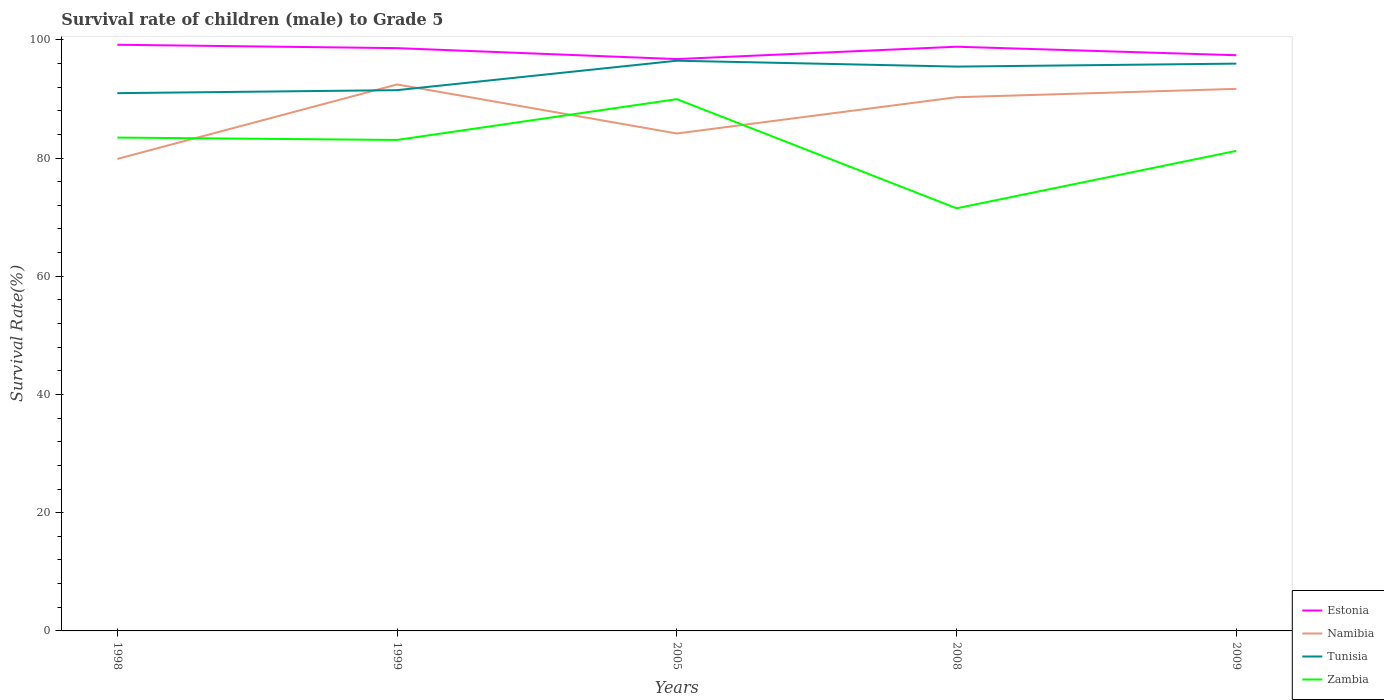Is the number of lines equal to the number of legend labels?
Your answer should be very brief. Yes. Across all years, what is the maximum survival rate of male children to grade 5 in Tunisia?
Ensure brevity in your answer.  90.97. In which year was the survival rate of male children to grade 5 in Estonia maximum?
Provide a succinct answer. 2005. What is the total survival rate of male children to grade 5 in Estonia in the graph?
Make the answer very short. 1.2. What is the difference between the highest and the second highest survival rate of male children to grade 5 in Estonia?
Give a very brief answer. 2.42. What is the difference between the highest and the lowest survival rate of male children to grade 5 in Zambia?
Ensure brevity in your answer.  3. How many years are there in the graph?
Offer a terse response. 5. Does the graph contain any zero values?
Ensure brevity in your answer.  No. Does the graph contain grids?
Your answer should be very brief. No. Where does the legend appear in the graph?
Your response must be concise. Bottom right. How many legend labels are there?
Your answer should be very brief. 4. How are the legend labels stacked?
Offer a terse response. Vertical. What is the title of the graph?
Offer a very short reply. Survival rate of children (male) to Grade 5. What is the label or title of the X-axis?
Offer a terse response. Years. What is the label or title of the Y-axis?
Keep it short and to the point. Survival Rate(%). What is the Survival Rate(%) in Estonia in 1998?
Offer a terse response. 99.16. What is the Survival Rate(%) of Namibia in 1998?
Your answer should be very brief. 79.85. What is the Survival Rate(%) in Tunisia in 1998?
Provide a short and direct response. 90.97. What is the Survival Rate(%) in Zambia in 1998?
Make the answer very short. 83.46. What is the Survival Rate(%) of Estonia in 1999?
Keep it short and to the point. 98.59. What is the Survival Rate(%) in Namibia in 1999?
Your answer should be compact. 92.45. What is the Survival Rate(%) of Tunisia in 1999?
Keep it short and to the point. 91.48. What is the Survival Rate(%) in Zambia in 1999?
Provide a short and direct response. 83.06. What is the Survival Rate(%) of Estonia in 2005?
Offer a very short reply. 96.74. What is the Survival Rate(%) of Namibia in 2005?
Give a very brief answer. 84.15. What is the Survival Rate(%) of Tunisia in 2005?
Your answer should be compact. 96.46. What is the Survival Rate(%) of Zambia in 2005?
Your answer should be very brief. 89.96. What is the Survival Rate(%) in Estonia in 2008?
Offer a terse response. 98.83. What is the Survival Rate(%) in Namibia in 2008?
Your answer should be very brief. 90.28. What is the Survival Rate(%) of Tunisia in 2008?
Your answer should be compact. 95.47. What is the Survival Rate(%) of Zambia in 2008?
Ensure brevity in your answer.  71.5. What is the Survival Rate(%) of Estonia in 2009?
Give a very brief answer. 97.39. What is the Survival Rate(%) in Namibia in 2009?
Offer a terse response. 91.7. What is the Survival Rate(%) in Tunisia in 2009?
Provide a short and direct response. 95.97. What is the Survival Rate(%) in Zambia in 2009?
Your answer should be very brief. 81.21. Across all years, what is the maximum Survival Rate(%) in Estonia?
Provide a succinct answer. 99.16. Across all years, what is the maximum Survival Rate(%) in Namibia?
Your answer should be compact. 92.45. Across all years, what is the maximum Survival Rate(%) of Tunisia?
Keep it short and to the point. 96.46. Across all years, what is the maximum Survival Rate(%) of Zambia?
Your answer should be very brief. 89.96. Across all years, what is the minimum Survival Rate(%) in Estonia?
Offer a terse response. 96.74. Across all years, what is the minimum Survival Rate(%) of Namibia?
Offer a very short reply. 79.85. Across all years, what is the minimum Survival Rate(%) of Tunisia?
Provide a short and direct response. 90.97. Across all years, what is the minimum Survival Rate(%) of Zambia?
Make the answer very short. 71.5. What is the total Survival Rate(%) in Estonia in the graph?
Offer a very short reply. 490.71. What is the total Survival Rate(%) in Namibia in the graph?
Offer a very short reply. 438.43. What is the total Survival Rate(%) in Tunisia in the graph?
Your response must be concise. 470.36. What is the total Survival Rate(%) in Zambia in the graph?
Your answer should be very brief. 409.19. What is the difference between the Survival Rate(%) of Estonia in 1998 and that in 1999?
Give a very brief answer. 0.57. What is the difference between the Survival Rate(%) of Namibia in 1998 and that in 1999?
Offer a terse response. -12.6. What is the difference between the Survival Rate(%) in Tunisia in 1998 and that in 1999?
Your response must be concise. -0.51. What is the difference between the Survival Rate(%) in Zambia in 1998 and that in 1999?
Make the answer very short. 0.4. What is the difference between the Survival Rate(%) in Estonia in 1998 and that in 2005?
Provide a short and direct response. 2.42. What is the difference between the Survival Rate(%) of Namibia in 1998 and that in 2005?
Offer a terse response. -4.31. What is the difference between the Survival Rate(%) of Tunisia in 1998 and that in 2005?
Your response must be concise. -5.49. What is the difference between the Survival Rate(%) in Zambia in 1998 and that in 2005?
Your answer should be compact. -6.5. What is the difference between the Survival Rate(%) of Estonia in 1998 and that in 2008?
Provide a succinct answer. 0.33. What is the difference between the Survival Rate(%) of Namibia in 1998 and that in 2008?
Keep it short and to the point. -10.44. What is the difference between the Survival Rate(%) in Tunisia in 1998 and that in 2008?
Your response must be concise. -4.5. What is the difference between the Survival Rate(%) in Zambia in 1998 and that in 2008?
Keep it short and to the point. 11.96. What is the difference between the Survival Rate(%) of Estonia in 1998 and that in 2009?
Your response must be concise. 1.77. What is the difference between the Survival Rate(%) in Namibia in 1998 and that in 2009?
Keep it short and to the point. -11.86. What is the difference between the Survival Rate(%) of Tunisia in 1998 and that in 2009?
Offer a terse response. -5. What is the difference between the Survival Rate(%) in Zambia in 1998 and that in 2009?
Your answer should be compact. 2.25. What is the difference between the Survival Rate(%) of Estonia in 1999 and that in 2005?
Offer a very short reply. 1.85. What is the difference between the Survival Rate(%) in Namibia in 1999 and that in 2005?
Give a very brief answer. 8.29. What is the difference between the Survival Rate(%) in Tunisia in 1999 and that in 2005?
Make the answer very short. -4.98. What is the difference between the Survival Rate(%) in Zambia in 1999 and that in 2005?
Your response must be concise. -6.9. What is the difference between the Survival Rate(%) in Estonia in 1999 and that in 2008?
Offer a very short reply. -0.24. What is the difference between the Survival Rate(%) of Namibia in 1999 and that in 2008?
Make the answer very short. 2.16. What is the difference between the Survival Rate(%) of Tunisia in 1999 and that in 2008?
Make the answer very short. -3.99. What is the difference between the Survival Rate(%) of Zambia in 1999 and that in 2008?
Keep it short and to the point. 11.56. What is the difference between the Survival Rate(%) of Estonia in 1999 and that in 2009?
Your answer should be very brief. 1.2. What is the difference between the Survival Rate(%) in Namibia in 1999 and that in 2009?
Ensure brevity in your answer.  0.75. What is the difference between the Survival Rate(%) of Tunisia in 1999 and that in 2009?
Your response must be concise. -4.49. What is the difference between the Survival Rate(%) in Zambia in 1999 and that in 2009?
Ensure brevity in your answer.  1.85. What is the difference between the Survival Rate(%) of Estonia in 2005 and that in 2008?
Offer a very short reply. -2.09. What is the difference between the Survival Rate(%) of Namibia in 2005 and that in 2008?
Your response must be concise. -6.13. What is the difference between the Survival Rate(%) of Tunisia in 2005 and that in 2008?
Your answer should be very brief. 0.99. What is the difference between the Survival Rate(%) of Zambia in 2005 and that in 2008?
Your answer should be very brief. 18.46. What is the difference between the Survival Rate(%) in Estonia in 2005 and that in 2009?
Give a very brief answer. -0.65. What is the difference between the Survival Rate(%) of Namibia in 2005 and that in 2009?
Your answer should be compact. -7.55. What is the difference between the Survival Rate(%) in Tunisia in 2005 and that in 2009?
Offer a very short reply. 0.49. What is the difference between the Survival Rate(%) of Zambia in 2005 and that in 2009?
Provide a succinct answer. 8.75. What is the difference between the Survival Rate(%) of Estonia in 2008 and that in 2009?
Keep it short and to the point. 1.44. What is the difference between the Survival Rate(%) of Namibia in 2008 and that in 2009?
Give a very brief answer. -1.42. What is the difference between the Survival Rate(%) in Tunisia in 2008 and that in 2009?
Your answer should be compact. -0.5. What is the difference between the Survival Rate(%) in Zambia in 2008 and that in 2009?
Offer a very short reply. -9.72. What is the difference between the Survival Rate(%) of Estonia in 1998 and the Survival Rate(%) of Namibia in 1999?
Offer a very short reply. 6.72. What is the difference between the Survival Rate(%) in Estonia in 1998 and the Survival Rate(%) in Tunisia in 1999?
Offer a very short reply. 7.68. What is the difference between the Survival Rate(%) of Estonia in 1998 and the Survival Rate(%) of Zambia in 1999?
Give a very brief answer. 16.1. What is the difference between the Survival Rate(%) in Namibia in 1998 and the Survival Rate(%) in Tunisia in 1999?
Your response must be concise. -11.64. What is the difference between the Survival Rate(%) of Namibia in 1998 and the Survival Rate(%) of Zambia in 1999?
Make the answer very short. -3.21. What is the difference between the Survival Rate(%) in Tunisia in 1998 and the Survival Rate(%) in Zambia in 1999?
Ensure brevity in your answer.  7.91. What is the difference between the Survival Rate(%) of Estonia in 1998 and the Survival Rate(%) of Namibia in 2005?
Ensure brevity in your answer.  15.01. What is the difference between the Survival Rate(%) of Estonia in 1998 and the Survival Rate(%) of Tunisia in 2005?
Ensure brevity in your answer.  2.7. What is the difference between the Survival Rate(%) in Estonia in 1998 and the Survival Rate(%) in Zambia in 2005?
Provide a succinct answer. 9.2. What is the difference between the Survival Rate(%) in Namibia in 1998 and the Survival Rate(%) in Tunisia in 2005?
Give a very brief answer. -16.62. What is the difference between the Survival Rate(%) in Namibia in 1998 and the Survival Rate(%) in Zambia in 2005?
Your answer should be very brief. -10.11. What is the difference between the Survival Rate(%) of Tunisia in 1998 and the Survival Rate(%) of Zambia in 2005?
Provide a short and direct response. 1.01. What is the difference between the Survival Rate(%) in Estonia in 1998 and the Survival Rate(%) in Namibia in 2008?
Your answer should be very brief. 8.88. What is the difference between the Survival Rate(%) of Estonia in 1998 and the Survival Rate(%) of Tunisia in 2008?
Ensure brevity in your answer.  3.69. What is the difference between the Survival Rate(%) in Estonia in 1998 and the Survival Rate(%) in Zambia in 2008?
Ensure brevity in your answer.  27.67. What is the difference between the Survival Rate(%) in Namibia in 1998 and the Survival Rate(%) in Tunisia in 2008?
Make the answer very short. -15.62. What is the difference between the Survival Rate(%) in Namibia in 1998 and the Survival Rate(%) in Zambia in 2008?
Your response must be concise. 8.35. What is the difference between the Survival Rate(%) of Tunisia in 1998 and the Survival Rate(%) of Zambia in 2008?
Provide a short and direct response. 19.48. What is the difference between the Survival Rate(%) in Estonia in 1998 and the Survival Rate(%) in Namibia in 2009?
Provide a succinct answer. 7.46. What is the difference between the Survival Rate(%) in Estonia in 1998 and the Survival Rate(%) in Tunisia in 2009?
Keep it short and to the point. 3.19. What is the difference between the Survival Rate(%) of Estonia in 1998 and the Survival Rate(%) of Zambia in 2009?
Give a very brief answer. 17.95. What is the difference between the Survival Rate(%) of Namibia in 1998 and the Survival Rate(%) of Tunisia in 2009?
Your response must be concise. -16.12. What is the difference between the Survival Rate(%) in Namibia in 1998 and the Survival Rate(%) in Zambia in 2009?
Your answer should be compact. -1.37. What is the difference between the Survival Rate(%) of Tunisia in 1998 and the Survival Rate(%) of Zambia in 2009?
Provide a short and direct response. 9.76. What is the difference between the Survival Rate(%) in Estonia in 1999 and the Survival Rate(%) in Namibia in 2005?
Ensure brevity in your answer.  14.44. What is the difference between the Survival Rate(%) in Estonia in 1999 and the Survival Rate(%) in Tunisia in 2005?
Your answer should be compact. 2.13. What is the difference between the Survival Rate(%) of Estonia in 1999 and the Survival Rate(%) of Zambia in 2005?
Your answer should be compact. 8.63. What is the difference between the Survival Rate(%) of Namibia in 1999 and the Survival Rate(%) of Tunisia in 2005?
Give a very brief answer. -4.02. What is the difference between the Survival Rate(%) of Namibia in 1999 and the Survival Rate(%) of Zambia in 2005?
Ensure brevity in your answer.  2.49. What is the difference between the Survival Rate(%) in Tunisia in 1999 and the Survival Rate(%) in Zambia in 2005?
Make the answer very short. 1.52. What is the difference between the Survival Rate(%) of Estonia in 1999 and the Survival Rate(%) of Namibia in 2008?
Provide a succinct answer. 8.31. What is the difference between the Survival Rate(%) in Estonia in 1999 and the Survival Rate(%) in Tunisia in 2008?
Ensure brevity in your answer.  3.12. What is the difference between the Survival Rate(%) of Estonia in 1999 and the Survival Rate(%) of Zambia in 2008?
Ensure brevity in your answer.  27.09. What is the difference between the Survival Rate(%) in Namibia in 1999 and the Survival Rate(%) in Tunisia in 2008?
Your answer should be very brief. -3.02. What is the difference between the Survival Rate(%) of Namibia in 1999 and the Survival Rate(%) of Zambia in 2008?
Make the answer very short. 20.95. What is the difference between the Survival Rate(%) in Tunisia in 1999 and the Survival Rate(%) in Zambia in 2008?
Provide a succinct answer. 19.99. What is the difference between the Survival Rate(%) of Estonia in 1999 and the Survival Rate(%) of Namibia in 2009?
Your answer should be compact. 6.89. What is the difference between the Survival Rate(%) of Estonia in 1999 and the Survival Rate(%) of Tunisia in 2009?
Your response must be concise. 2.62. What is the difference between the Survival Rate(%) of Estonia in 1999 and the Survival Rate(%) of Zambia in 2009?
Offer a terse response. 17.38. What is the difference between the Survival Rate(%) in Namibia in 1999 and the Survival Rate(%) in Tunisia in 2009?
Ensure brevity in your answer.  -3.52. What is the difference between the Survival Rate(%) of Namibia in 1999 and the Survival Rate(%) of Zambia in 2009?
Provide a short and direct response. 11.23. What is the difference between the Survival Rate(%) in Tunisia in 1999 and the Survival Rate(%) in Zambia in 2009?
Your answer should be compact. 10.27. What is the difference between the Survival Rate(%) of Estonia in 2005 and the Survival Rate(%) of Namibia in 2008?
Your answer should be very brief. 6.46. What is the difference between the Survival Rate(%) of Estonia in 2005 and the Survival Rate(%) of Tunisia in 2008?
Provide a short and direct response. 1.27. What is the difference between the Survival Rate(%) of Estonia in 2005 and the Survival Rate(%) of Zambia in 2008?
Make the answer very short. 25.24. What is the difference between the Survival Rate(%) of Namibia in 2005 and the Survival Rate(%) of Tunisia in 2008?
Your answer should be compact. -11.32. What is the difference between the Survival Rate(%) in Namibia in 2005 and the Survival Rate(%) in Zambia in 2008?
Offer a very short reply. 12.66. What is the difference between the Survival Rate(%) in Tunisia in 2005 and the Survival Rate(%) in Zambia in 2008?
Offer a terse response. 24.97. What is the difference between the Survival Rate(%) in Estonia in 2005 and the Survival Rate(%) in Namibia in 2009?
Make the answer very short. 5.04. What is the difference between the Survival Rate(%) in Estonia in 2005 and the Survival Rate(%) in Tunisia in 2009?
Give a very brief answer. 0.77. What is the difference between the Survival Rate(%) in Estonia in 2005 and the Survival Rate(%) in Zambia in 2009?
Make the answer very short. 15.53. What is the difference between the Survival Rate(%) in Namibia in 2005 and the Survival Rate(%) in Tunisia in 2009?
Your answer should be very brief. -11.82. What is the difference between the Survival Rate(%) of Namibia in 2005 and the Survival Rate(%) of Zambia in 2009?
Provide a succinct answer. 2.94. What is the difference between the Survival Rate(%) of Tunisia in 2005 and the Survival Rate(%) of Zambia in 2009?
Your response must be concise. 15.25. What is the difference between the Survival Rate(%) in Estonia in 2008 and the Survival Rate(%) in Namibia in 2009?
Make the answer very short. 7.13. What is the difference between the Survival Rate(%) of Estonia in 2008 and the Survival Rate(%) of Tunisia in 2009?
Give a very brief answer. 2.86. What is the difference between the Survival Rate(%) of Estonia in 2008 and the Survival Rate(%) of Zambia in 2009?
Provide a succinct answer. 17.62. What is the difference between the Survival Rate(%) of Namibia in 2008 and the Survival Rate(%) of Tunisia in 2009?
Give a very brief answer. -5.69. What is the difference between the Survival Rate(%) of Namibia in 2008 and the Survival Rate(%) of Zambia in 2009?
Your answer should be very brief. 9.07. What is the difference between the Survival Rate(%) of Tunisia in 2008 and the Survival Rate(%) of Zambia in 2009?
Make the answer very short. 14.26. What is the average Survival Rate(%) in Estonia per year?
Your answer should be compact. 98.14. What is the average Survival Rate(%) in Namibia per year?
Give a very brief answer. 87.69. What is the average Survival Rate(%) in Tunisia per year?
Give a very brief answer. 94.07. What is the average Survival Rate(%) in Zambia per year?
Provide a short and direct response. 81.84. In the year 1998, what is the difference between the Survival Rate(%) of Estonia and Survival Rate(%) of Namibia?
Offer a very short reply. 19.32. In the year 1998, what is the difference between the Survival Rate(%) in Estonia and Survival Rate(%) in Tunisia?
Provide a short and direct response. 8.19. In the year 1998, what is the difference between the Survival Rate(%) of Estonia and Survival Rate(%) of Zambia?
Provide a short and direct response. 15.7. In the year 1998, what is the difference between the Survival Rate(%) in Namibia and Survival Rate(%) in Tunisia?
Offer a very short reply. -11.13. In the year 1998, what is the difference between the Survival Rate(%) in Namibia and Survival Rate(%) in Zambia?
Your answer should be very brief. -3.61. In the year 1998, what is the difference between the Survival Rate(%) in Tunisia and Survival Rate(%) in Zambia?
Provide a succinct answer. 7.51. In the year 1999, what is the difference between the Survival Rate(%) of Estonia and Survival Rate(%) of Namibia?
Make the answer very short. 6.14. In the year 1999, what is the difference between the Survival Rate(%) of Estonia and Survival Rate(%) of Tunisia?
Give a very brief answer. 7.11. In the year 1999, what is the difference between the Survival Rate(%) of Estonia and Survival Rate(%) of Zambia?
Your answer should be very brief. 15.53. In the year 1999, what is the difference between the Survival Rate(%) in Namibia and Survival Rate(%) in Tunisia?
Offer a very short reply. 0.96. In the year 1999, what is the difference between the Survival Rate(%) in Namibia and Survival Rate(%) in Zambia?
Ensure brevity in your answer.  9.39. In the year 1999, what is the difference between the Survival Rate(%) of Tunisia and Survival Rate(%) of Zambia?
Make the answer very short. 8.42. In the year 2005, what is the difference between the Survival Rate(%) of Estonia and Survival Rate(%) of Namibia?
Give a very brief answer. 12.59. In the year 2005, what is the difference between the Survival Rate(%) in Estonia and Survival Rate(%) in Tunisia?
Offer a terse response. 0.28. In the year 2005, what is the difference between the Survival Rate(%) in Estonia and Survival Rate(%) in Zambia?
Keep it short and to the point. 6.78. In the year 2005, what is the difference between the Survival Rate(%) in Namibia and Survival Rate(%) in Tunisia?
Your response must be concise. -12.31. In the year 2005, what is the difference between the Survival Rate(%) of Namibia and Survival Rate(%) of Zambia?
Give a very brief answer. -5.81. In the year 2005, what is the difference between the Survival Rate(%) of Tunisia and Survival Rate(%) of Zambia?
Make the answer very short. 6.5. In the year 2008, what is the difference between the Survival Rate(%) of Estonia and Survival Rate(%) of Namibia?
Provide a succinct answer. 8.55. In the year 2008, what is the difference between the Survival Rate(%) of Estonia and Survival Rate(%) of Tunisia?
Your answer should be compact. 3.36. In the year 2008, what is the difference between the Survival Rate(%) of Estonia and Survival Rate(%) of Zambia?
Give a very brief answer. 27.34. In the year 2008, what is the difference between the Survival Rate(%) of Namibia and Survival Rate(%) of Tunisia?
Give a very brief answer. -5.19. In the year 2008, what is the difference between the Survival Rate(%) in Namibia and Survival Rate(%) in Zambia?
Give a very brief answer. 18.79. In the year 2008, what is the difference between the Survival Rate(%) of Tunisia and Survival Rate(%) of Zambia?
Provide a short and direct response. 23.97. In the year 2009, what is the difference between the Survival Rate(%) of Estonia and Survival Rate(%) of Namibia?
Ensure brevity in your answer.  5.69. In the year 2009, what is the difference between the Survival Rate(%) of Estonia and Survival Rate(%) of Tunisia?
Your response must be concise. 1.42. In the year 2009, what is the difference between the Survival Rate(%) in Estonia and Survival Rate(%) in Zambia?
Make the answer very short. 16.18. In the year 2009, what is the difference between the Survival Rate(%) of Namibia and Survival Rate(%) of Tunisia?
Your response must be concise. -4.27. In the year 2009, what is the difference between the Survival Rate(%) in Namibia and Survival Rate(%) in Zambia?
Your answer should be compact. 10.49. In the year 2009, what is the difference between the Survival Rate(%) of Tunisia and Survival Rate(%) of Zambia?
Offer a very short reply. 14.76. What is the ratio of the Survival Rate(%) of Estonia in 1998 to that in 1999?
Provide a succinct answer. 1.01. What is the ratio of the Survival Rate(%) of Namibia in 1998 to that in 1999?
Your answer should be compact. 0.86. What is the ratio of the Survival Rate(%) in Tunisia in 1998 to that in 1999?
Give a very brief answer. 0.99. What is the ratio of the Survival Rate(%) in Estonia in 1998 to that in 2005?
Give a very brief answer. 1.03. What is the ratio of the Survival Rate(%) of Namibia in 1998 to that in 2005?
Your response must be concise. 0.95. What is the ratio of the Survival Rate(%) of Tunisia in 1998 to that in 2005?
Give a very brief answer. 0.94. What is the ratio of the Survival Rate(%) in Zambia in 1998 to that in 2005?
Your answer should be very brief. 0.93. What is the ratio of the Survival Rate(%) of Namibia in 1998 to that in 2008?
Provide a short and direct response. 0.88. What is the ratio of the Survival Rate(%) in Tunisia in 1998 to that in 2008?
Offer a very short reply. 0.95. What is the ratio of the Survival Rate(%) in Zambia in 1998 to that in 2008?
Give a very brief answer. 1.17. What is the ratio of the Survival Rate(%) in Estonia in 1998 to that in 2009?
Provide a short and direct response. 1.02. What is the ratio of the Survival Rate(%) in Namibia in 1998 to that in 2009?
Offer a terse response. 0.87. What is the ratio of the Survival Rate(%) of Tunisia in 1998 to that in 2009?
Keep it short and to the point. 0.95. What is the ratio of the Survival Rate(%) in Zambia in 1998 to that in 2009?
Ensure brevity in your answer.  1.03. What is the ratio of the Survival Rate(%) of Estonia in 1999 to that in 2005?
Offer a terse response. 1.02. What is the ratio of the Survival Rate(%) of Namibia in 1999 to that in 2005?
Ensure brevity in your answer.  1.1. What is the ratio of the Survival Rate(%) in Tunisia in 1999 to that in 2005?
Offer a terse response. 0.95. What is the ratio of the Survival Rate(%) in Zambia in 1999 to that in 2005?
Give a very brief answer. 0.92. What is the ratio of the Survival Rate(%) in Estonia in 1999 to that in 2008?
Your response must be concise. 1. What is the ratio of the Survival Rate(%) in Zambia in 1999 to that in 2008?
Keep it short and to the point. 1.16. What is the ratio of the Survival Rate(%) of Estonia in 1999 to that in 2009?
Offer a very short reply. 1.01. What is the ratio of the Survival Rate(%) in Tunisia in 1999 to that in 2009?
Give a very brief answer. 0.95. What is the ratio of the Survival Rate(%) of Zambia in 1999 to that in 2009?
Your answer should be very brief. 1.02. What is the ratio of the Survival Rate(%) of Estonia in 2005 to that in 2008?
Give a very brief answer. 0.98. What is the ratio of the Survival Rate(%) in Namibia in 2005 to that in 2008?
Your response must be concise. 0.93. What is the ratio of the Survival Rate(%) in Tunisia in 2005 to that in 2008?
Your answer should be compact. 1.01. What is the ratio of the Survival Rate(%) in Zambia in 2005 to that in 2008?
Provide a short and direct response. 1.26. What is the ratio of the Survival Rate(%) in Namibia in 2005 to that in 2009?
Your answer should be very brief. 0.92. What is the ratio of the Survival Rate(%) in Zambia in 2005 to that in 2009?
Your answer should be compact. 1.11. What is the ratio of the Survival Rate(%) of Estonia in 2008 to that in 2009?
Offer a terse response. 1.01. What is the ratio of the Survival Rate(%) of Namibia in 2008 to that in 2009?
Your response must be concise. 0.98. What is the ratio of the Survival Rate(%) of Zambia in 2008 to that in 2009?
Offer a terse response. 0.88. What is the difference between the highest and the second highest Survival Rate(%) in Estonia?
Keep it short and to the point. 0.33. What is the difference between the highest and the second highest Survival Rate(%) in Namibia?
Make the answer very short. 0.75. What is the difference between the highest and the second highest Survival Rate(%) in Tunisia?
Keep it short and to the point. 0.49. What is the difference between the highest and the second highest Survival Rate(%) in Zambia?
Your answer should be compact. 6.5. What is the difference between the highest and the lowest Survival Rate(%) in Estonia?
Give a very brief answer. 2.42. What is the difference between the highest and the lowest Survival Rate(%) in Namibia?
Ensure brevity in your answer.  12.6. What is the difference between the highest and the lowest Survival Rate(%) in Tunisia?
Your response must be concise. 5.49. What is the difference between the highest and the lowest Survival Rate(%) of Zambia?
Provide a short and direct response. 18.46. 